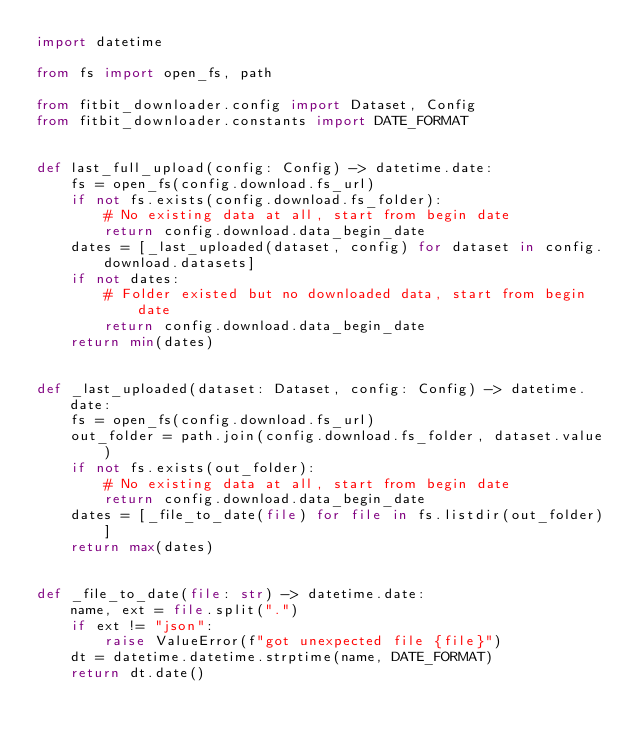Convert code to text. <code><loc_0><loc_0><loc_500><loc_500><_Python_>import datetime

from fs import open_fs, path

from fitbit_downloader.config import Dataset, Config
from fitbit_downloader.constants import DATE_FORMAT


def last_full_upload(config: Config) -> datetime.date:
    fs = open_fs(config.download.fs_url)
    if not fs.exists(config.download.fs_folder):
        # No existing data at all, start from begin date
        return config.download.data_begin_date
    dates = [_last_uploaded(dataset, config) for dataset in config.download.datasets]
    if not dates:
        # Folder existed but no downloaded data, start from begin date
        return config.download.data_begin_date
    return min(dates)


def _last_uploaded(dataset: Dataset, config: Config) -> datetime.date:
    fs = open_fs(config.download.fs_url)
    out_folder = path.join(config.download.fs_folder, dataset.value)
    if not fs.exists(out_folder):
        # No existing data at all, start from begin date
        return config.download.data_begin_date
    dates = [_file_to_date(file) for file in fs.listdir(out_folder)]
    return max(dates)


def _file_to_date(file: str) -> datetime.date:
    name, ext = file.split(".")
    if ext != "json":
        raise ValueError(f"got unexpected file {file}")
    dt = datetime.datetime.strptime(name, DATE_FORMAT)
    return dt.date()
</code> 